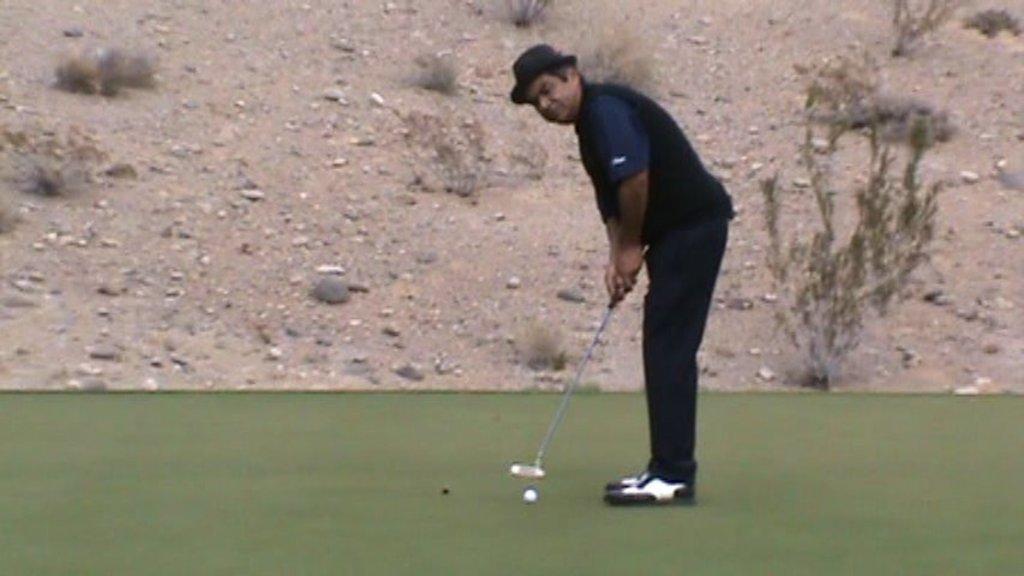Describe this image in one or two sentences. This image is taken outdoors. At the bottom of the image there is a golf court. In the middle of the image a man is standing and he is holding a golf stick and playing golf with a ball. In the background there is ground with pebbles and a few dry plants on it. 